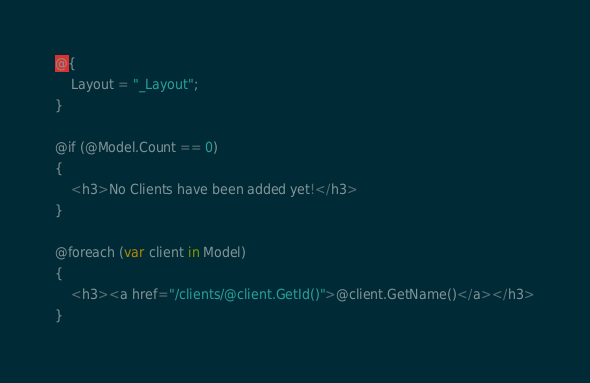Convert code to text. <code><loc_0><loc_0><loc_500><loc_500><_C#_>@{
    Layout = "_Layout";
}

@if (@Model.Count == 0)
{
    <h3>No Clients have been added yet!</h3>
}

@foreach (var client in Model)
{
    <h3><a href="/clients/@client.GetId()">@client.GetName()</a></h3>
}
</code> 